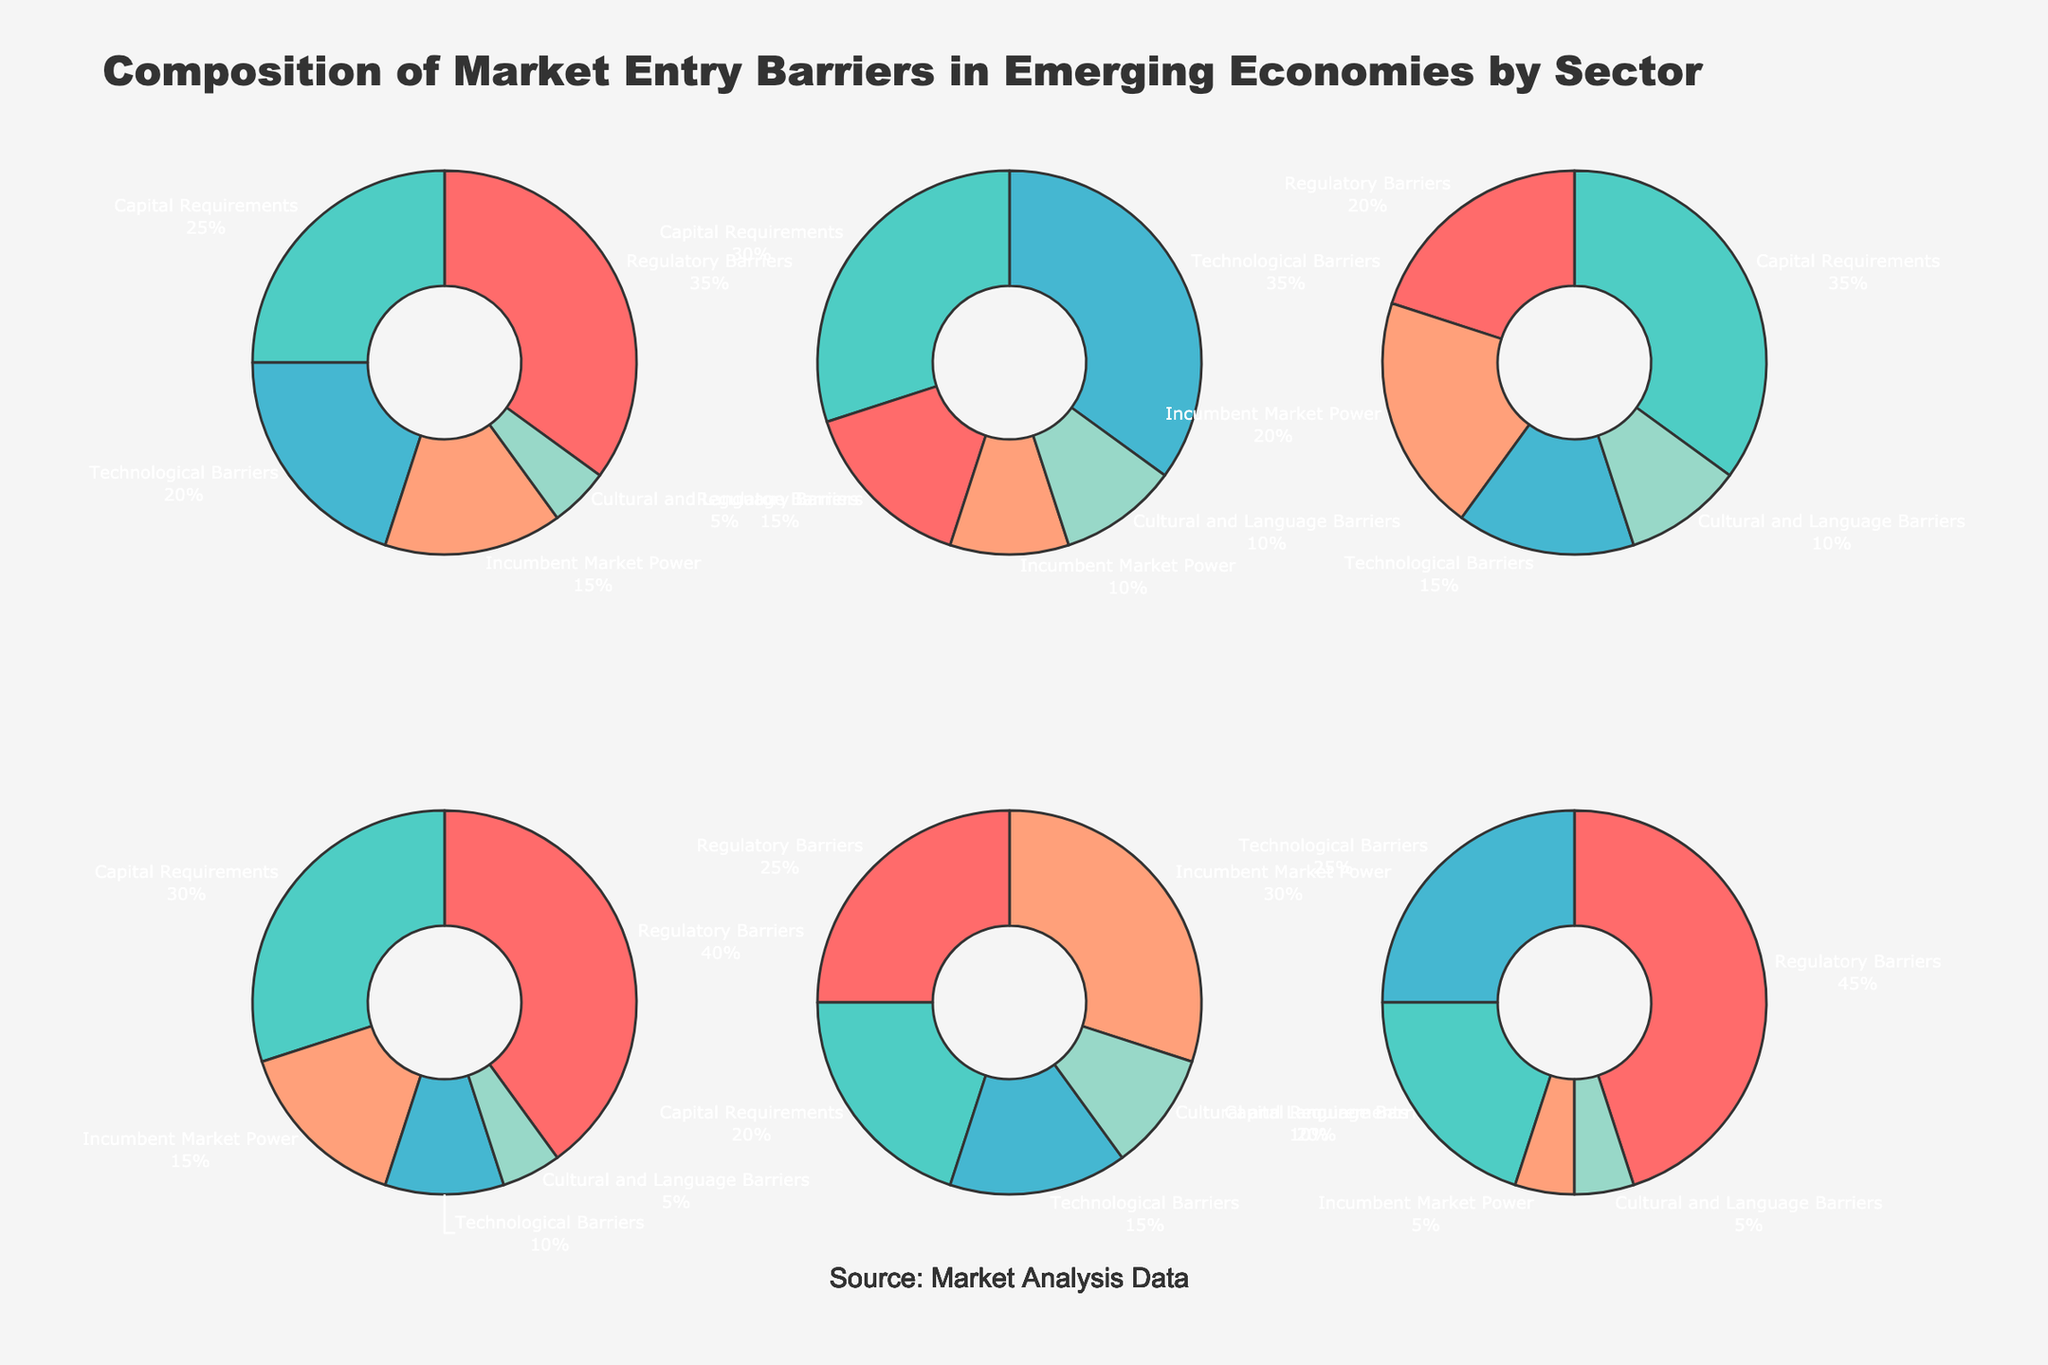what's the title of the figure? The title of the figure is usually displayed at the top of the chart and provides an overview of what the figure represents. The title here explains the content of the pie charts.
Answer: Composition of Market Entry Barriers in Emerging Economies by Sector Which sector has the highest percentage of regulatory barriers? To find this, look at the pie segments labeled "Regulatory Barriers" and compare their sizes across different sectors.
Answer: Healthcare For the manufacturing sector, what is the combined percentage of capital requirements and technological barriers? Identify the percentages for capital requirements and technological barriers in the manufacturing sector and add them together: 25% + 20%.
Answer: 45% Which sector has the smallest share of cultural and language barriers? Identify the pie segment labeled "Cultural and Language Barriers" for each sector and compare their sizes to find the smallest one.
Answer: Healthcare and Financial Services (both 5%) What is the visual distribution of market power barriers in the agriculture sector? Look at the pie chart for the agriculture sector and find the segment labeled "Incumbent Market Power" to understand its visual share.
Answer: 30% Compare the percentage of capital requirements between the technology and retail sectors. Which is higher? Extract the capital requirements percentages for both sectors and compare them: Technology (30%) vs Retail (35%).
Answer: Retail Which sectors have a higher percentage of technological barriers than regulatory barriers? Compare the segments labeled "Technological Barriers" and "Regulatory Barriers" for each sector and identify where the former is greater.
Answer: Technology Calculate the average percentage of incumbent market power barriers across all sectors. Sum the incumbent market power percentages for all sectors and divide by the number of sectors: (15% + 10% + 20% +15% + 30% + 5%) / 6.
Answer: 15.83% Which sector’s entry barriers have the most uniform distribution? Visualize all pie charts and identify the one with the least extreme variations in segment sizes.
Answer: Technology In which sector do capital requirements and technological barriers together make up more than 50% of the entry barriers? For each sector, sum the percentages for capital requirements and technological barriers and check if the total exceeds 50%.
Answer: Technology and Retail 